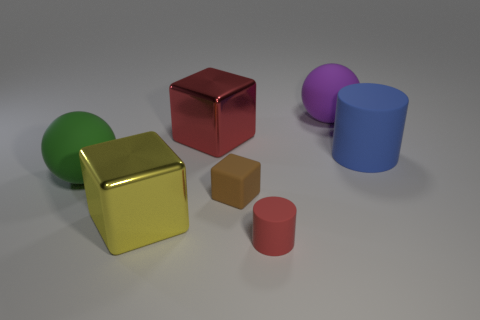The other matte object that is the same shape as the green object is what color?
Your answer should be very brief. Purple. How many big things have the same color as the small cylinder?
Offer a very short reply. 1. Does the matte thing behind the blue thing have the same shape as the blue object?
Ensure brevity in your answer.  No. What shape is the matte object left of the small thing to the left of the rubber thing in front of the brown rubber thing?
Your answer should be compact. Sphere. What size is the brown cube?
Provide a succinct answer. Small. The block that is made of the same material as the green object is what color?
Provide a short and direct response. Brown. How many blue objects have the same material as the big blue cylinder?
Provide a succinct answer. 0. There is a tiny cylinder; is it the same color as the metallic block behind the large cylinder?
Offer a terse response. Yes. What is the color of the big cube on the right side of the big thing in front of the brown thing?
Offer a very short reply. Red. The thing that is the same size as the red cylinder is what color?
Make the answer very short. Brown. 